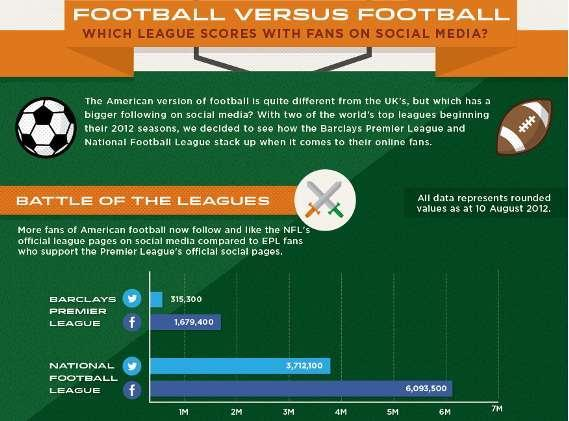What is the number of twitter followers of NFL as of 10 August 2012?
Answer the question with a short phrase. 3,712,100 What is the number of facebook followers of EPL as of 10 August 2012? 1,679,400 